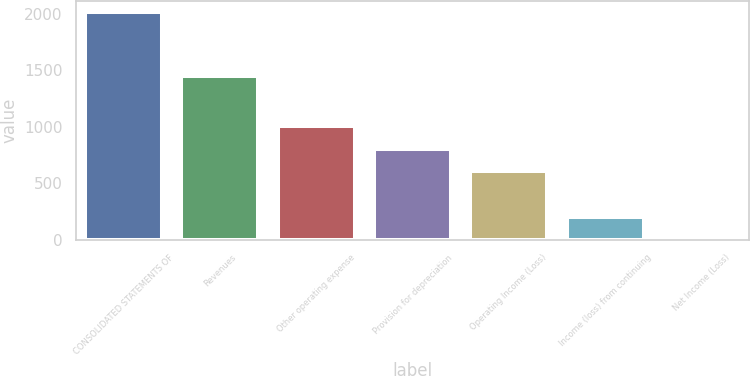Convert chart. <chart><loc_0><loc_0><loc_500><loc_500><bar_chart><fcel>CONSOLIDATED STATEMENTS OF<fcel>Revenues<fcel>Other operating expense<fcel>Provision for depreciation<fcel>Operating Income (Loss)<fcel>Income (loss) from continuing<fcel>Net Income (Loss)<nl><fcel>2012<fcel>1450<fcel>1006.5<fcel>805.4<fcel>604.3<fcel>202.1<fcel>1<nl></chart> 